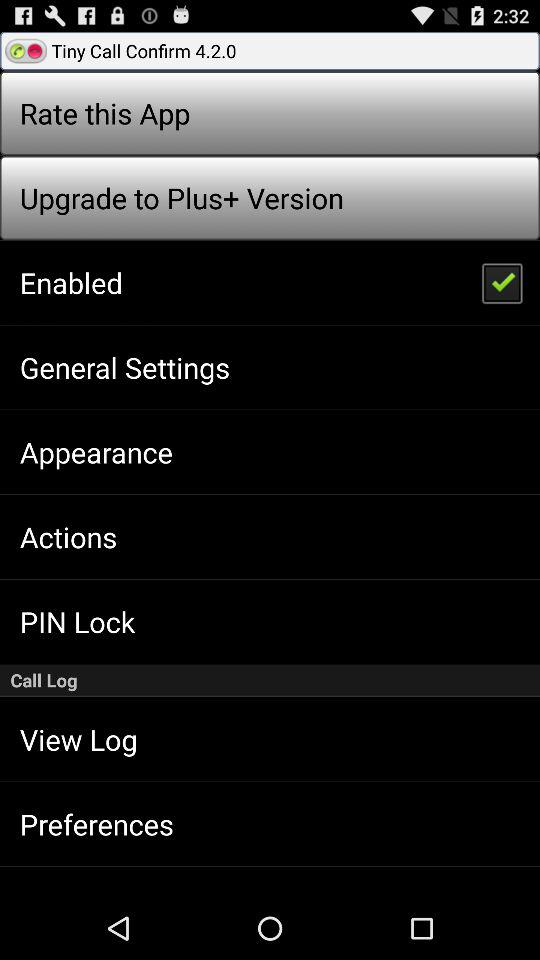What is the name of the application? The name of the application is "Tiny Call Confirm 4.2.0". 